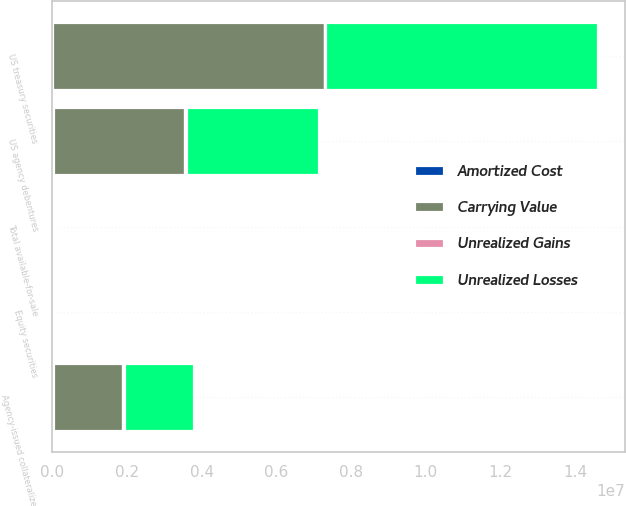Convert chart. <chart><loc_0><loc_0><loc_500><loc_500><stacked_bar_chart><ecel><fcel>US treasury securities<fcel>US agency debentures<fcel>Agency-issued collateralized<fcel>Equity securities<fcel>Total available-for-sale<nl><fcel>Carrying Value<fcel>7.28914e+06<fcel>3.54006e+06<fcel>1.88445e+06<fcel>5202<fcel>22833.5<nl><fcel>Unrealized Gains<fcel>17524<fcel>30478<fcel>14851<fcel>2628<fcel>70853<nl><fcel>Amortized Cost<fcel>4386<fcel>8977<fcel>14458<fcel>322<fcel>28143<nl><fcel>Unrealized Losses<fcel>7.30227e+06<fcel>3.56156e+06<fcel>1.88484e+06<fcel>7508<fcel>22833.5<nl></chart> 